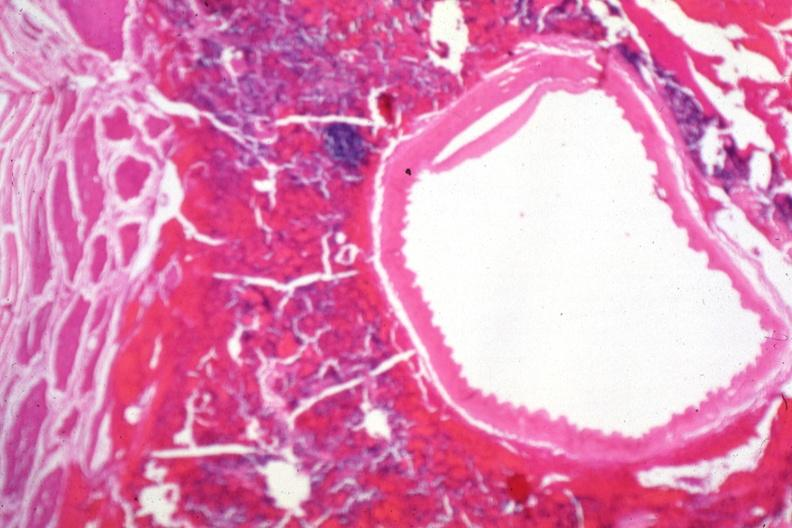what is present?
Answer the question using a single word or phrase. Malignant adenoma 